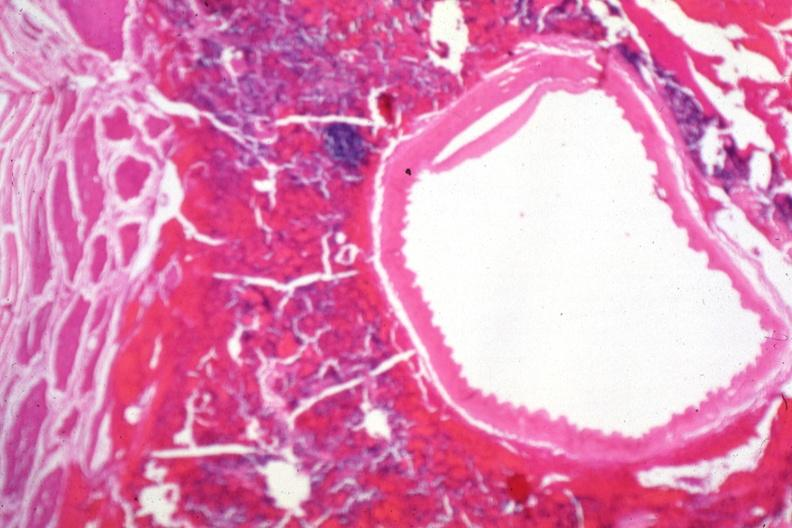what is present?
Answer the question using a single word or phrase. Malignant adenoma 